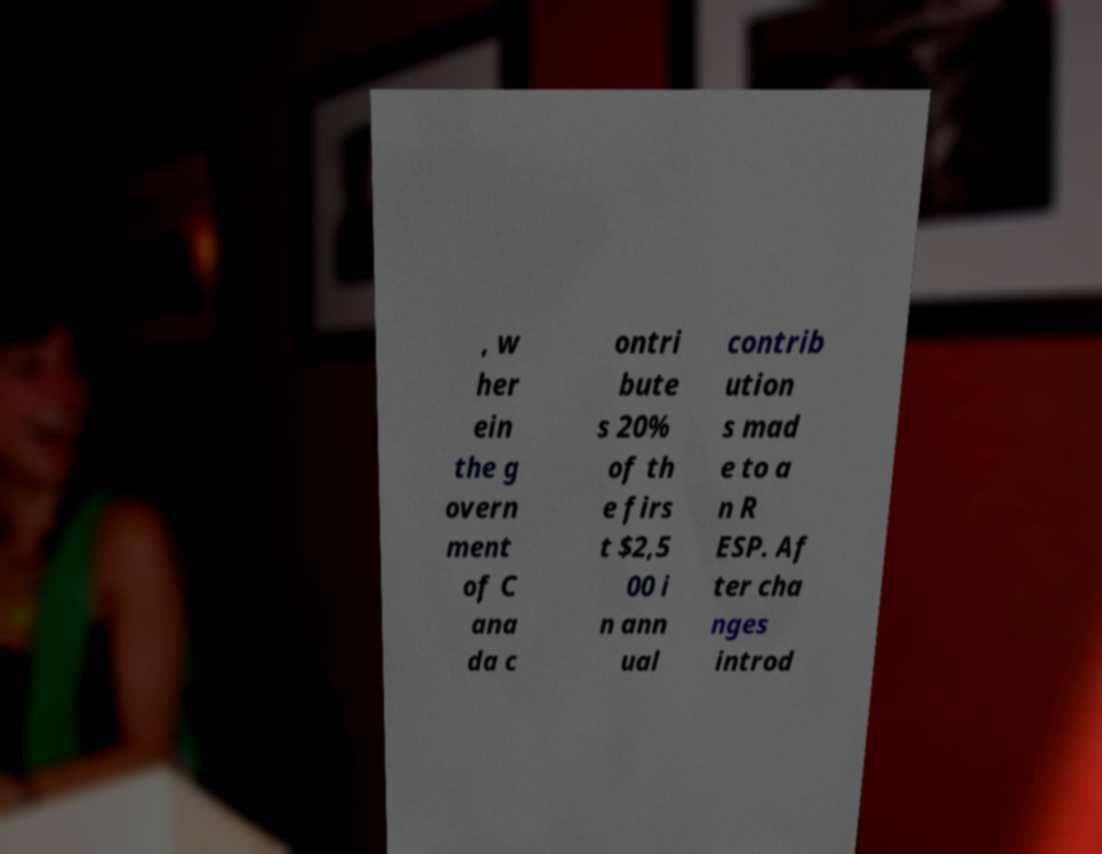Please identify and transcribe the text found in this image. , w her ein the g overn ment of C ana da c ontri bute s 20% of th e firs t $2,5 00 i n ann ual contrib ution s mad e to a n R ESP. Af ter cha nges introd 